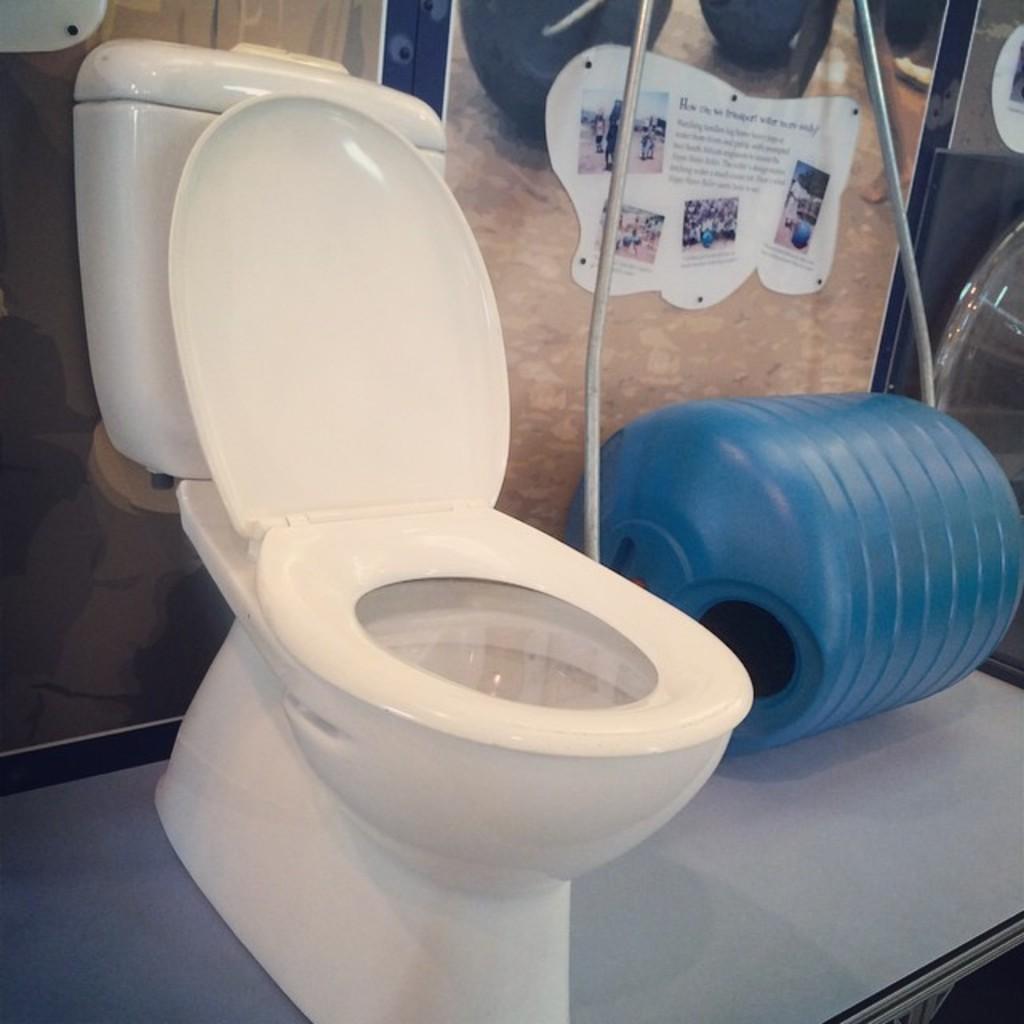How would you summarize this image in a sentence or two? This image is clicked in washroom. There is a toilet in the middle. There is a drum in the middle. It is in blue color. There is something pasted at the top. 